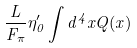Convert formula to latex. <formula><loc_0><loc_0><loc_500><loc_500>\frac { L } { F _ { \pi } } \eta ^ { \prime } _ { 0 } \int d ^ { 4 } x Q ( x )</formula> 